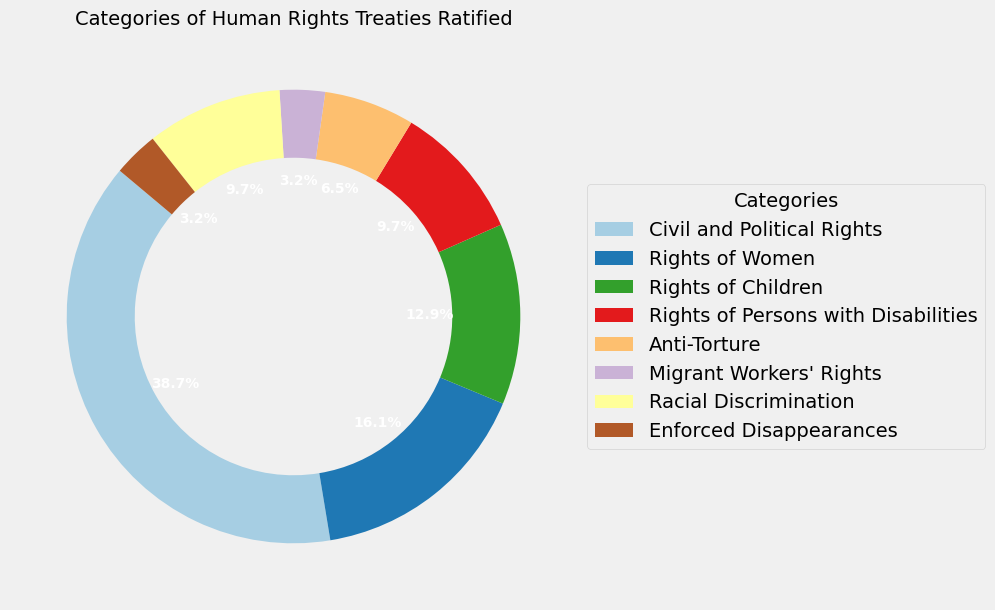What's the largest category in the chart? The largest category is identified by the section of the pie chart with the highest percentage. "Civil and Political Rights" occupies 12 treaties, the highest in the dataset.
Answer: Civil and Political Rights Which category has a smaller number of treaties: "Rights of Women" or "Rights of Persons with Disabilities"? "Rights of Women" has 5 treaties, and "Rights of Persons with Disabilities" has 3 treaties. By comparing these numbers, 3 is smaller than 5.
Answer: Rights of Persons with Disabilities How many total treaties were ratified for "Rights of Children", "Rights of Persons with Disabilities", and "Anti-Torture" combined? To get the total, sum up the treaties for the three categories: 4 (Rights of Children) + 3 (Rights of Persons with Disabilities) + 2 (Anti-Torture). Thus, 4 + 3 + 2 = 9 treaties.
Answer: 9 What percentage of the treaties are related to racial discrimination? "Racial Discrimination" has 3 treaties. The total number of treaties is 31. The percentage is calculated as (3/31) * 100 = 9.7%.
Answer: 9.7% Which segment is colored blue? Examine the pie chart's legend to find the color blue and the corresponding category. Based on standard order or personal inspection, let's determine that it's "Anti-Torture".
Answer: Anti-Torture How many types of treaties have been ratified more than 5 treaties? By looking at the numbers in each category, only "Civil and Political Rights" has more than 5 treaties.
Answer: 1 Which is the smallest category on the chart? The smallest category in the pie chart has the least number of treaties, which is 1. Two categories fit: "Migrant Workers' Rights" and "Enforced Disappearances."
Answer: Migrant Workers' Rights, Enforced Disappearances What is the combined share (in percentage) of "Migrant Workers' Rights" and "Enforced Disappearances"? Both categories have 1 treaty each. Combined, they have 2 out of 31 total treaties. The percentage share is calculated as (2/31) * 100 = 6.5%.
Answer: 6.5% Which category forms approximately 16.1% of the total treaties? The category's percentage closest to 16.1% is derived from dividing the category's treaties by the total number and then multiplying by 100. By checking different trials, "Rights of Women" (5 treaties) has 16.1%.
Answer: Rights of Women 